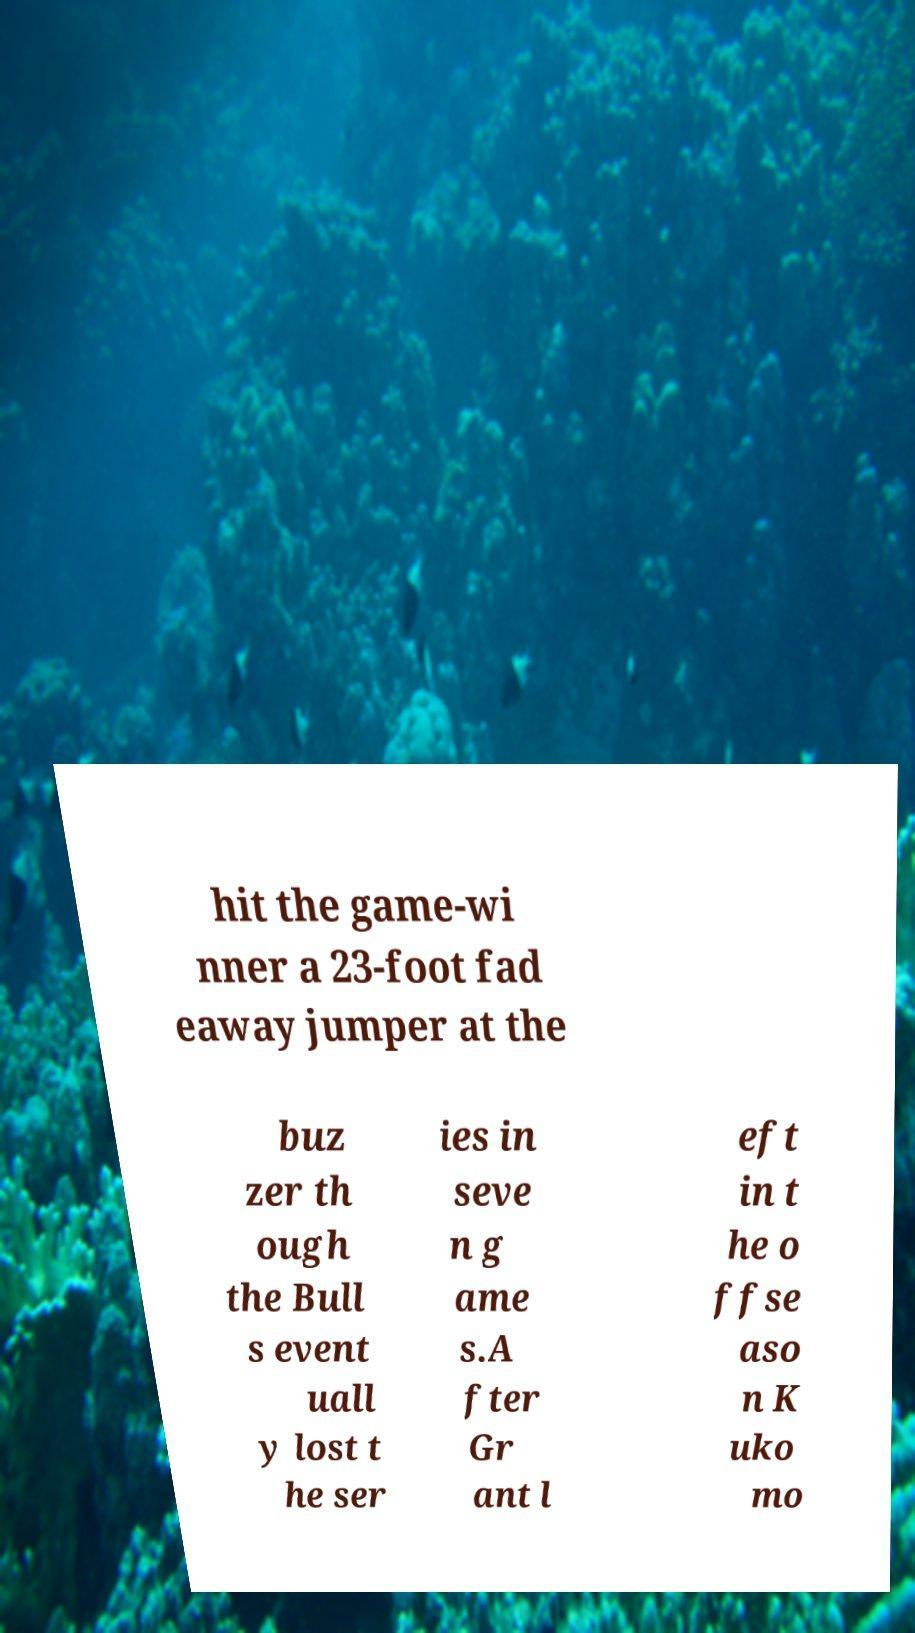For documentation purposes, I need the text within this image transcribed. Could you provide that? hit the game-wi nner a 23-foot fad eaway jumper at the buz zer th ough the Bull s event uall y lost t he ser ies in seve n g ame s.A fter Gr ant l eft in t he o ffse aso n K uko mo 